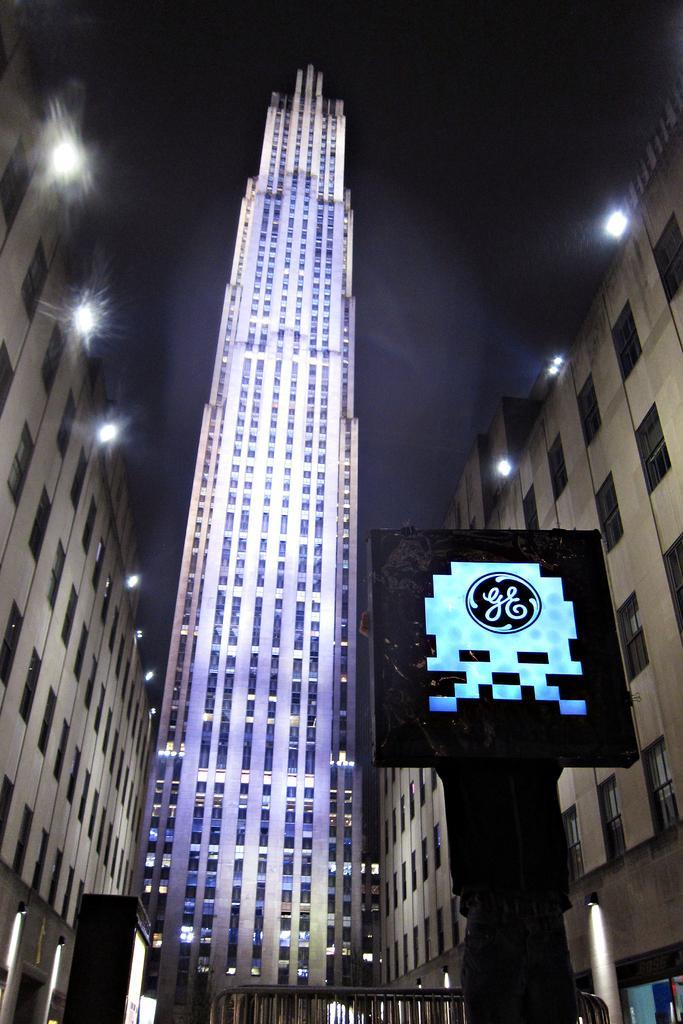Could you give a brief overview of what you see in this image? In this image we can see buildings, lights, objects, a person holding an object in the hands and the sky. 